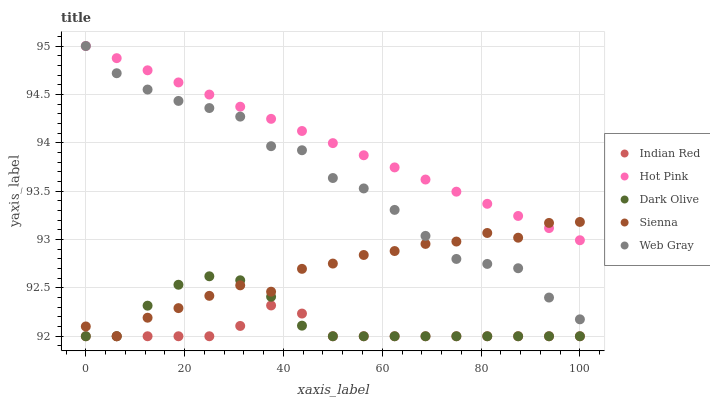Does Indian Red have the minimum area under the curve?
Answer yes or no. Yes. Does Hot Pink have the maximum area under the curve?
Answer yes or no. Yes. Does Sienna have the minimum area under the curve?
Answer yes or no. No. Does Sienna have the maximum area under the curve?
Answer yes or no. No. Is Hot Pink the smoothest?
Answer yes or no. Yes. Is Web Gray the roughest?
Answer yes or no. Yes. Is Sienna the smoothest?
Answer yes or no. No. Is Sienna the roughest?
Answer yes or no. No. Does Dark Olive have the lowest value?
Answer yes or no. Yes. Does Hot Pink have the lowest value?
Answer yes or no. No. Does Web Gray have the highest value?
Answer yes or no. Yes. Does Sienna have the highest value?
Answer yes or no. No. Is Dark Olive less than Hot Pink?
Answer yes or no. Yes. Is Hot Pink greater than Dark Olive?
Answer yes or no. Yes. Does Sienna intersect Indian Red?
Answer yes or no. Yes. Is Sienna less than Indian Red?
Answer yes or no. No. Is Sienna greater than Indian Red?
Answer yes or no. No. Does Dark Olive intersect Hot Pink?
Answer yes or no. No. 